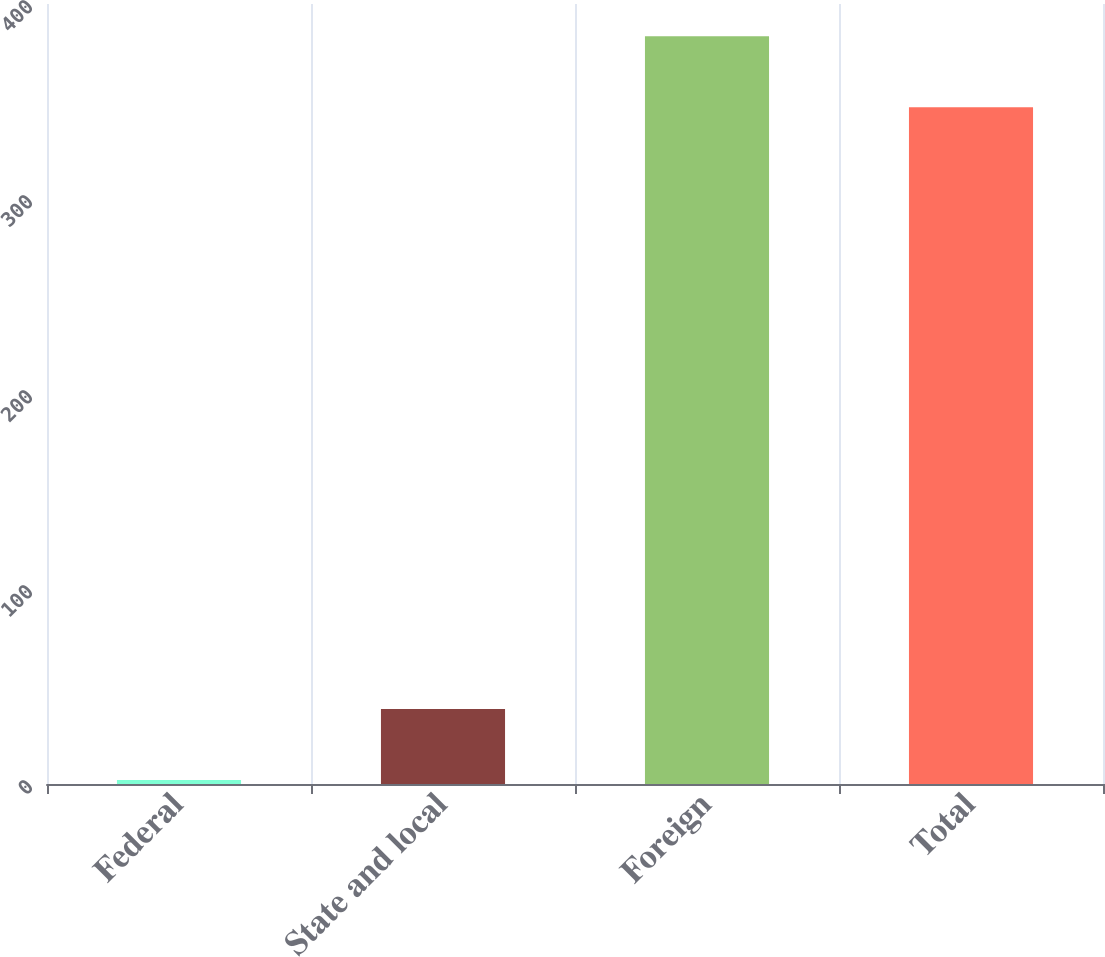<chart> <loc_0><loc_0><loc_500><loc_500><bar_chart><fcel>Federal<fcel>State and local<fcel>Foreign<fcel>Total<nl><fcel>2<fcel>38.5<fcel>383.5<fcel>347<nl></chart> 